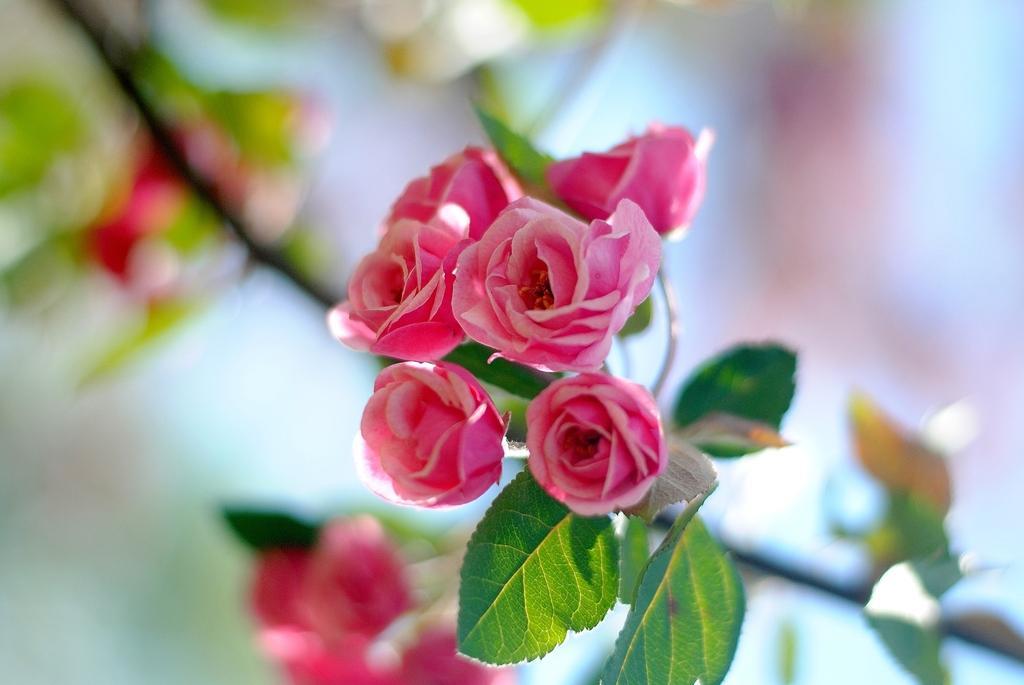Can you describe this image briefly? In this image in the foreground there are rose flowers and there are some leaves, and there is a blurry background. 